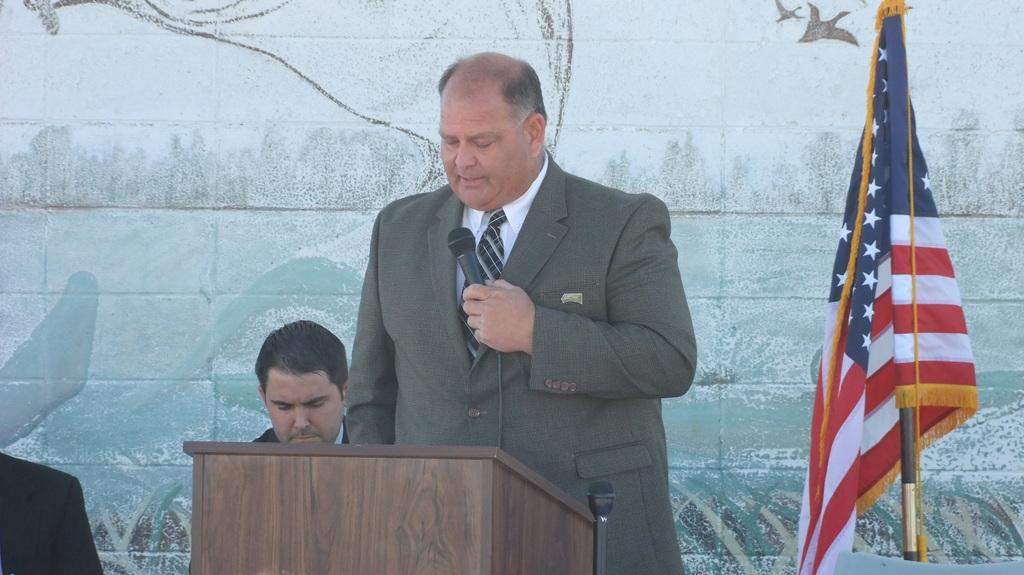How many people are in the image? There are people in the image, but the exact number is not specified. What is the person near the podium doing? The person is standing near a podium and speaking into a microphone. What can be seen on the right side of the image? There is a flag on the right side of the image. What is hanging on the wall in the image? There is a painting on the wall in the image. What type of rod is being used to hold up the painting in the image? There is no rod visible in the image; the painting is hanging on the wall. 